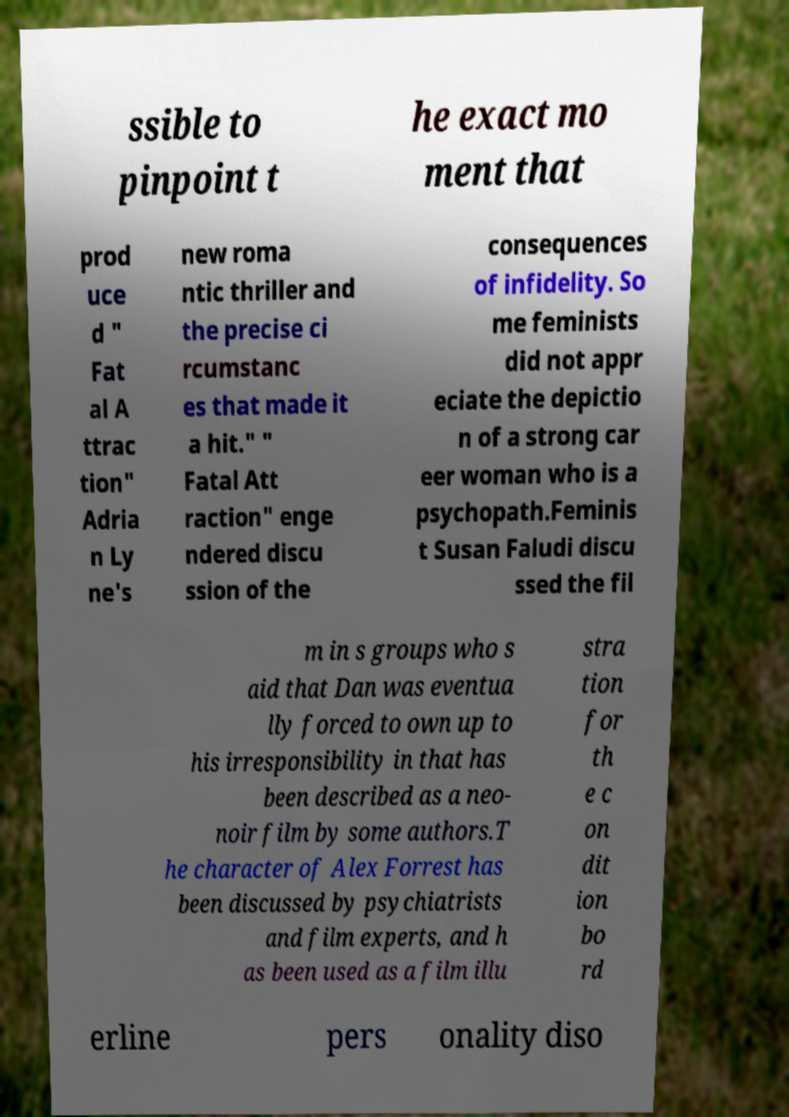I need the written content from this picture converted into text. Can you do that? ssible to pinpoint t he exact mo ment that prod uce d " Fat al A ttrac tion" Adria n Ly ne's new roma ntic thriller and the precise ci rcumstanc es that made it a hit." " Fatal Att raction" enge ndered discu ssion of the consequences of infidelity. So me feminists did not appr eciate the depictio n of a strong car eer woman who is a psychopath.Feminis t Susan Faludi discu ssed the fil m in s groups who s aid that Dan was eventua lly forced to own up to his irresponsibility in that has been described as a neo- noir film by some authors.T he character of Alex Forrest has been discussed by psychiatrists and film experts, and h as been used as a film illu stra tion for th e c on dit ion bo rd erline pers onality diso 